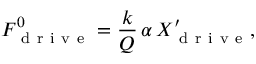<formula> <loc_0><loc_0><loc_500><loc_500>F _ { d r i v e } ^ { 0 } = \frac { k } { Q } \, \alpha \, X _ { d r i v e } ^ { \prime } ,</formula> 